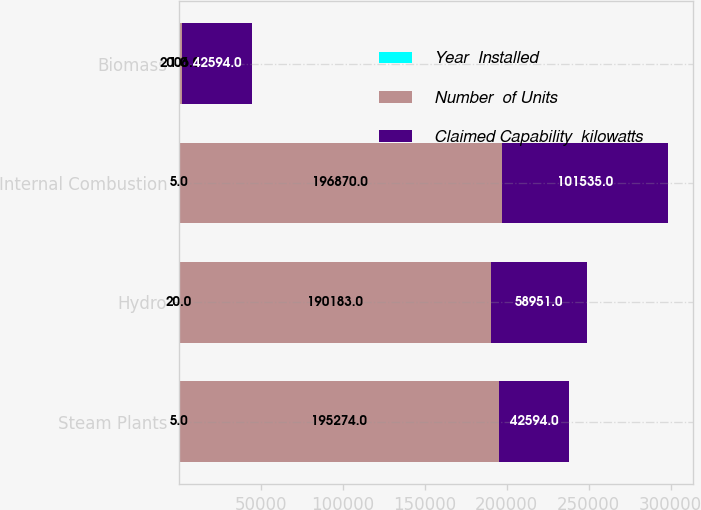Convert chart to OTSL. <chart><loc_0><loc_0><loc_500><loc_500><stacked_bar_chart><ecel><fcel>Steam Plants<fcel>Hydro<fcel>Internal Combustion<fcel>Biomass<nl><fcel>Year  Installed<fcel>5<fcel>20<fcel>5<fcel>1<nl><fcel>Number  of Units<fcel>195274<fcel>190183<fcel>196870<fcel>2006<nl><fcel>Claimed Capability  kilowatts<fcel>42594<fcel>58951<fcel>101535<fcel>42594<nl></chart> 